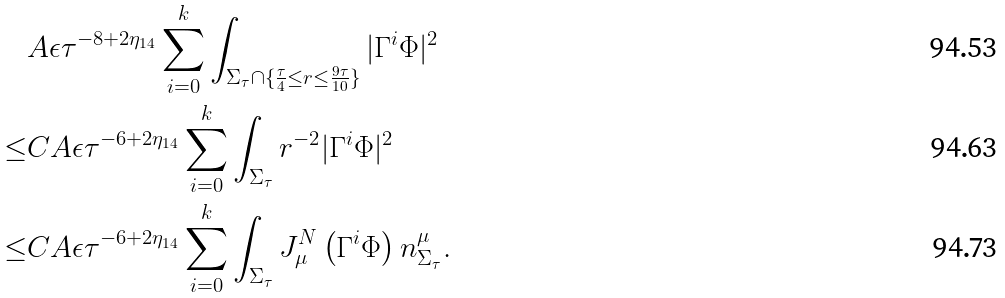Convert formula to latex. <formula><loc_0><loc_0><loc_500><loc_500>& A \epsilon \tau ^ { - 8 + 2 \eta _ { 1 4 } } \sum _ { i = 0 } ^ { k } \int _ { \Sigma _ { \tau } \cap \{ \frac { \tau } { 4 } \leq r \leq \frac { 9 \tau } { 1 0 } \} } | \Gamma ^ { i } \Phi | ^ { 2 } \\ \leq & C A \epsilon \tau ^ { - 6 + 2 \eta _ { 1 4 } } \sum _ { i = 0 } ^ { k } \int _ { \Sigma _ { \tau } } r ^ { - 2 } | \Gamma ^ { i } \Phi | ^ { 2 } \\ \leq & C A \epsilon \tau ^ { - 6 + 2 \eta _ { 1 4 } } \sum _ { i = 0 } ^ { k } \int _ { \Sigma _ { \tau } } J ^ { N } _ { \mu } \left ( \Gamma ^ { i } \Phi \right ) n ^ { \mu } _ { \Sigma _ { \tau } } .</formula> 